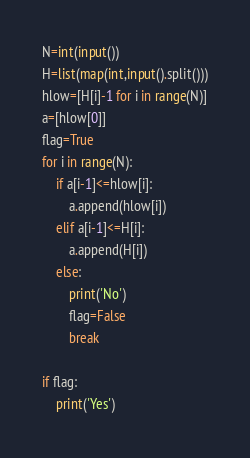Convert code to text. <code><loc_0><loc_0><loc_500><loc_500><_Python_>N=int(input())
H=list(map(int,input().split()))
hlow=[H[i]-1 for i in range(N)]
a=[hlow[0]]
flag=True
for i in range(N):
    if a[i-1]<=hlow[i]:
        a.append(hlow[i])
    elif a[i-1]<=H[i]:
        a.append(H[i])
    else:
        print('No')
        flag=False
        break

if flag:
    print('Yes')</code> 